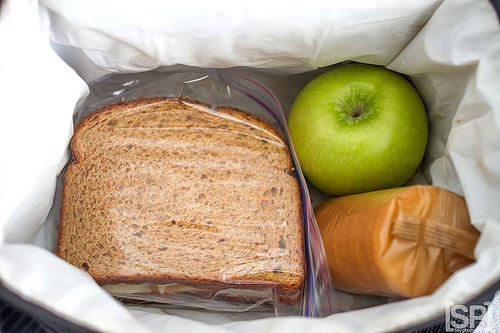<image>
Is there a sandwich in the crackers? No. The sandwich is not contained within the crackers. These objects have a different spatial relationship. 